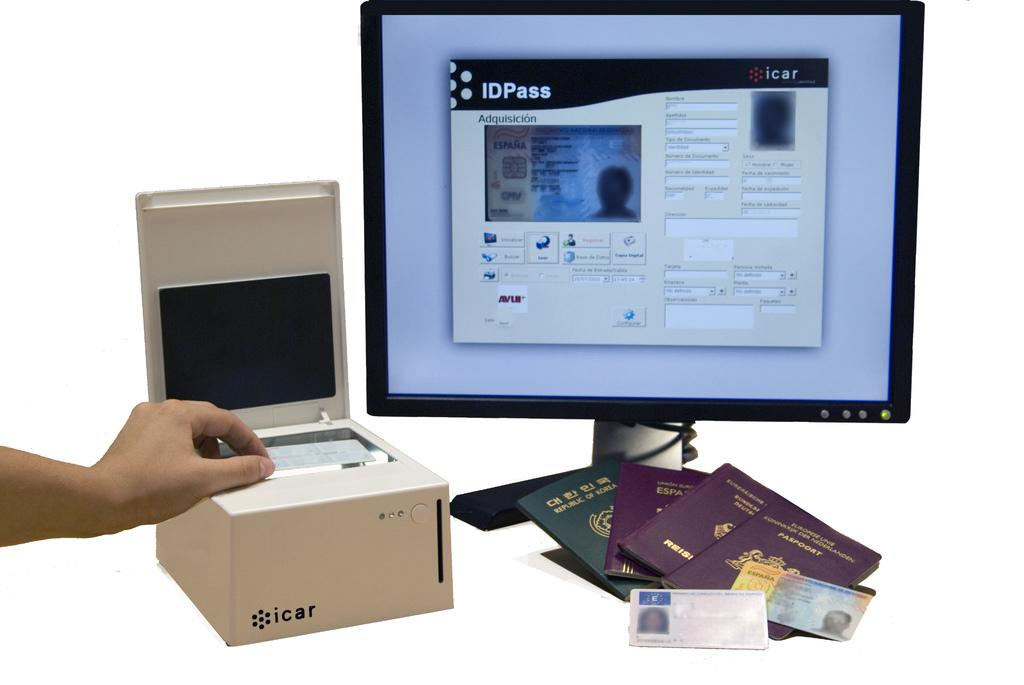What electronic device is present in the image? There is a computer monitor in the image. What travel documents can be seen in the image? There are passports in the image. What type of small, flat objects are visible in the image? There are cards in the image. Whose hand is visible in the image? A person's hand is visible in the image. What color is the background of the image? The background of the image is white. What type of vase is present on the computer monitor in the image? There is no vase present on the computer monitor in the image. Is there a veil visible in the image? There is no veil present in the image. 